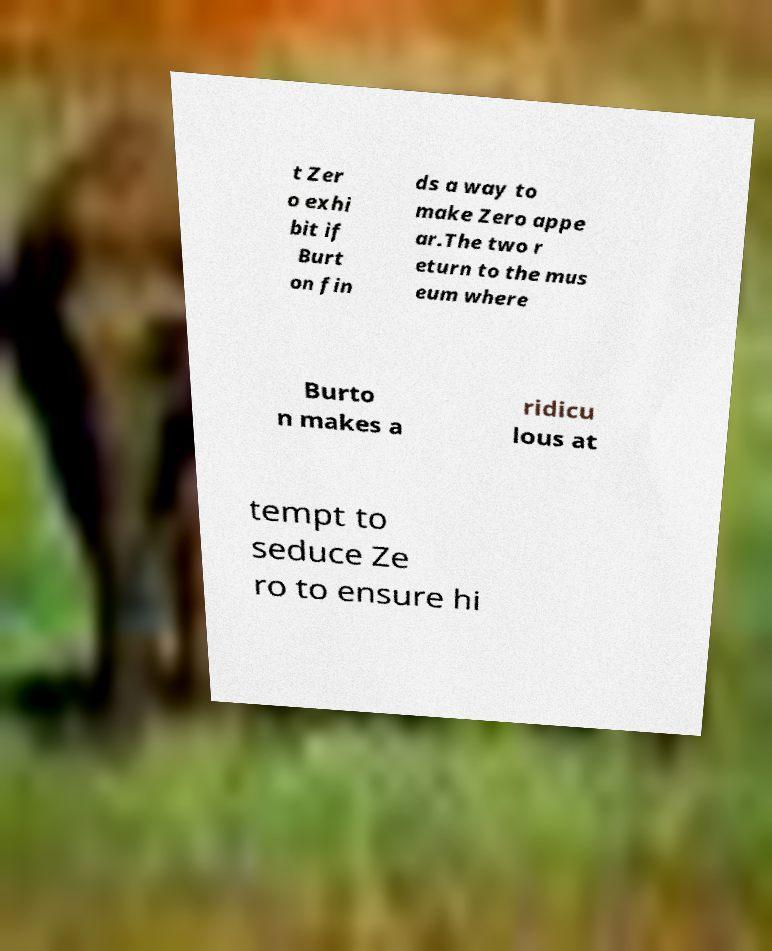I need the written content from this picture converted into text. Can you do that? t Zer o exhi bit if Burt on fin ds a way to make Zero appe ar.The two r eturn to the mus eum where Burto n makes a ridicu lous at tempt to seduce Ze ro to ensure hi 